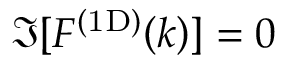<formula> <loc_0><loc_0><loc_500><loc_500>\Im [ \ m a t h i n n e r { F ^ { ( 1 D ) } \left ( k \right ) } ] = 0</formula> 